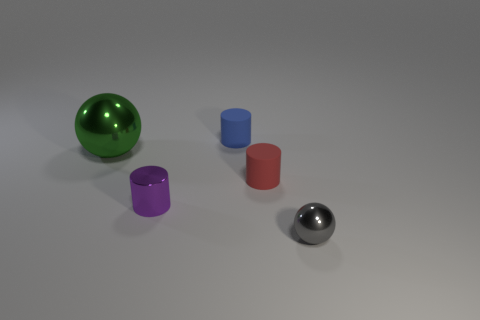Are there fewer tiny matte cylinders that are right of the red object than tiny red matte objects that are in front of the small gray metallic object?
Keep it short and to the point. No. Are there any small purple metallic cylinders in front of the blue matte object?
Ensure brevity in your answer.  Yes. How many objects are either tiny objects that are on the left side of the small red cylinder or blue matte cylinders that are behind the large ball?
Give a very brief answer. 2. How many cylinders have the same color as the big object?
Your response must be concise. 0. What color is the other object that is the same shape as the big object?
Make the answer very short. Gray. The thing that is behind the metallic cylinder and on the left side of the small blue cylinder has what shape?
Offer a terse response. Sphere. Is the number of small blue rubber objects greater than the number of big cyan matte cubes?
Provide a succinct answer. Yes. What material is the blue thing?
Your answer should be compact. Rubber. Is there anything else that is the same size as the blue cylinder?
Provide a succinct answer. Yes. There is a blue matte thing that is the same shape as the purple thing; what size is it?
Give a very brief answer. Small. 